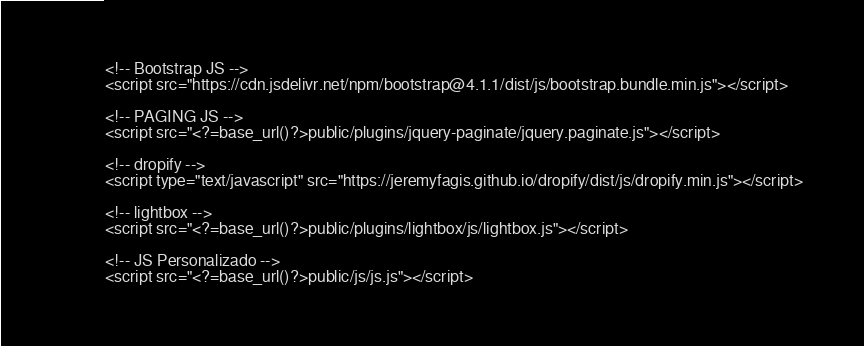Convert code to text. <code><loc_0><loc_0><loc_500><loc_500><_PHP_>
<!-- Bootstrap JS -->
<script src="https://cdn.jsdelivr.net/npm/bootstrap@4.1.1/dist/js/bootstrap.bundle.min.js"></script>

<!-- PAGING JS -->
<script src="<?=base_url()?>public/plugins/jquery-paginate/jquery.paginate.js"></script>

<!-- dropify -->
<script type="text/javascript" src="https://jeremyfagis.github.io/dropify/dist/js/dropify.min.js"></script>

<!-- lightbox -->
<script src="<?=base_url()?>public/plugins/lightbox/js/lightbox.js"></script>

<!-- JS Personalizado -->
<script src="<?=base_url()?>public/js/js.js"></script>

</code> 